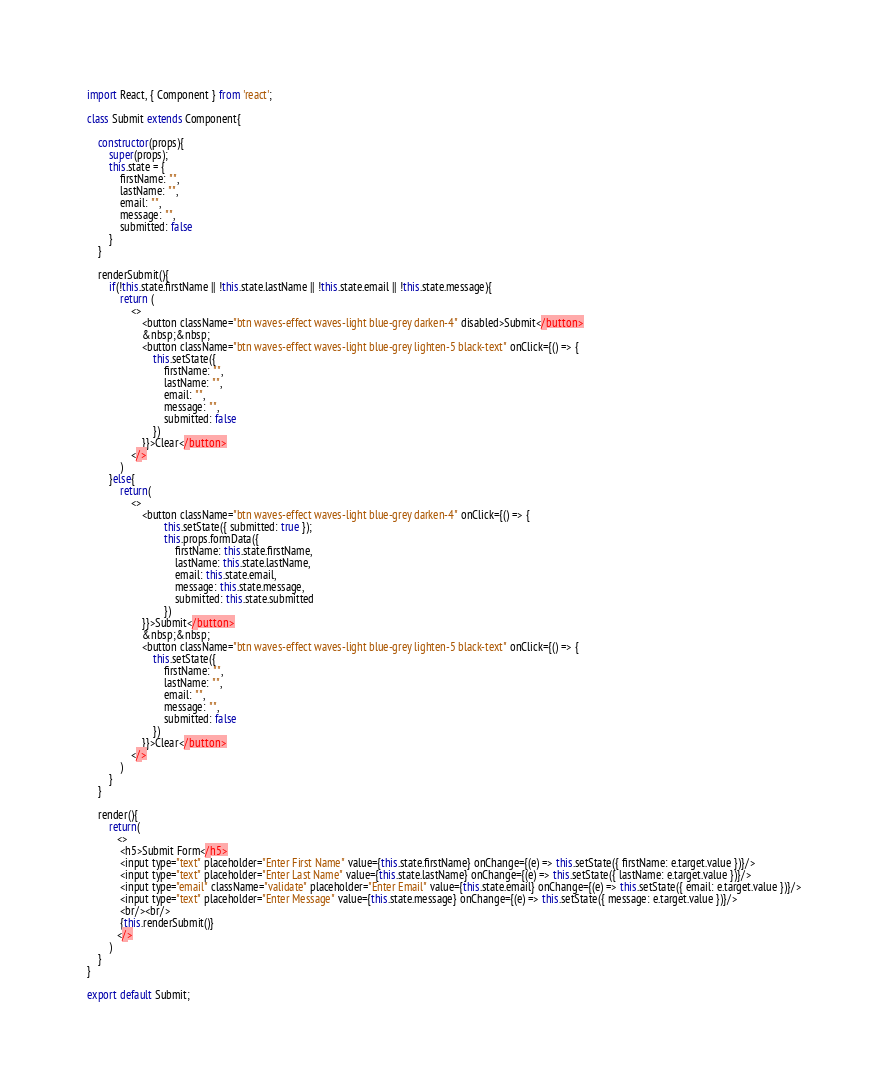<code> <loc_0><loc_0><loc_500><loc_500><_JavaScript_>import React, { Component } from 'react';

class Submit extends Component{

    constructor(props){
        super(props);
        this.state = {
            firstName: "",
            lastName: "",
            email: "",
            message: "",
            submitted: false
        }
    }
    
    renderSubmit(){
        if(!this.state.firstName || !this.state.lastName || !this.state.email || !this.state.message){
            return (
                <>
                    <button className="btn waves-effect waves-light blue-grey darken-4" disabled>Submit</button>
                    &nbsp;&nbsp;
                    <button className="btn waves-effect waves-light blue-grey lighten-5 black-text" onClick={() => {
                        this.setState({
                            firstName: "",
                            lastName: "",
                            email: "",
                            message: "",
                            submitted: false
                        })
                    }}>Clear</button>
                </>
            )
        }else{
            return(
                <>
                    <button className="btn waves-effect waves-light blue-grey darken-4" onClick={() => {
                            this.setState({ submitted: true });
                            this.props.formData({
                                firstName: this.state.firstName,
                                lastName: this.state.lastName,
                                email: this.state.email,
                                message: this.state.message,
                                submitted: this.state.submitted
                            })
                    }}>Submit</button>
                    &nbsp;&nbsp;
                    <button className="btn waves-effect waves-light blue-grey lighten-5 black-text" onClick={() => {
                        this.setState({
                            firstName: "",
                            lastName: "",
                            email: "",
                            message: "",
                            submitted: false
                        })
                    }}>Clear</button>
                </>
            )
        }
    }

    render(){
        return(
           <>
            <h5>Submit Form</h5>
            <input type="text" placeholder="Enter First Name" value={this.state.firstName} onChange={(e) => this.setState({ firstName: e.target.value })}/>
            <input type="text" placeholder="Enter Last Name" value={this.state.lastName} onChange={(e) => this.setState({ lastName: e.target.value })}/>
            <input type="email" className="validate" placeholder="Enter Email" value={this.state.email} onChange={(e) => this.setState({ email: e.target.value })}/>
            <input type="text" placeholder="Enter Message" value={this.state.message} onChange={(e) => this.setState({ message: e.target.value })}/>
            <br/><br/>
            {this.renderSubmit()}
           </>
        )
    }
}

export default Submit;</code> 